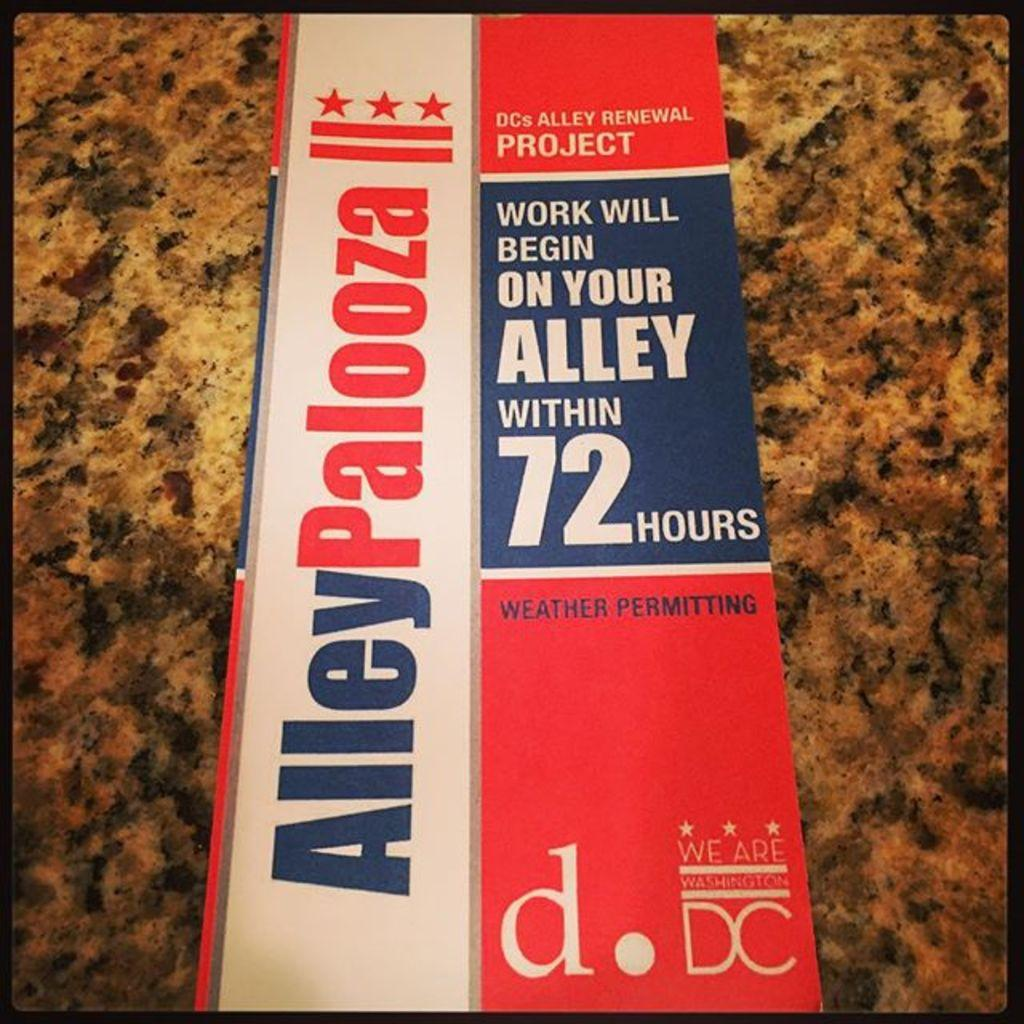<image>
Render a clear and concise summary of the photo. A red, white, and blue pamphlet about the DC Alley Renewal project. 